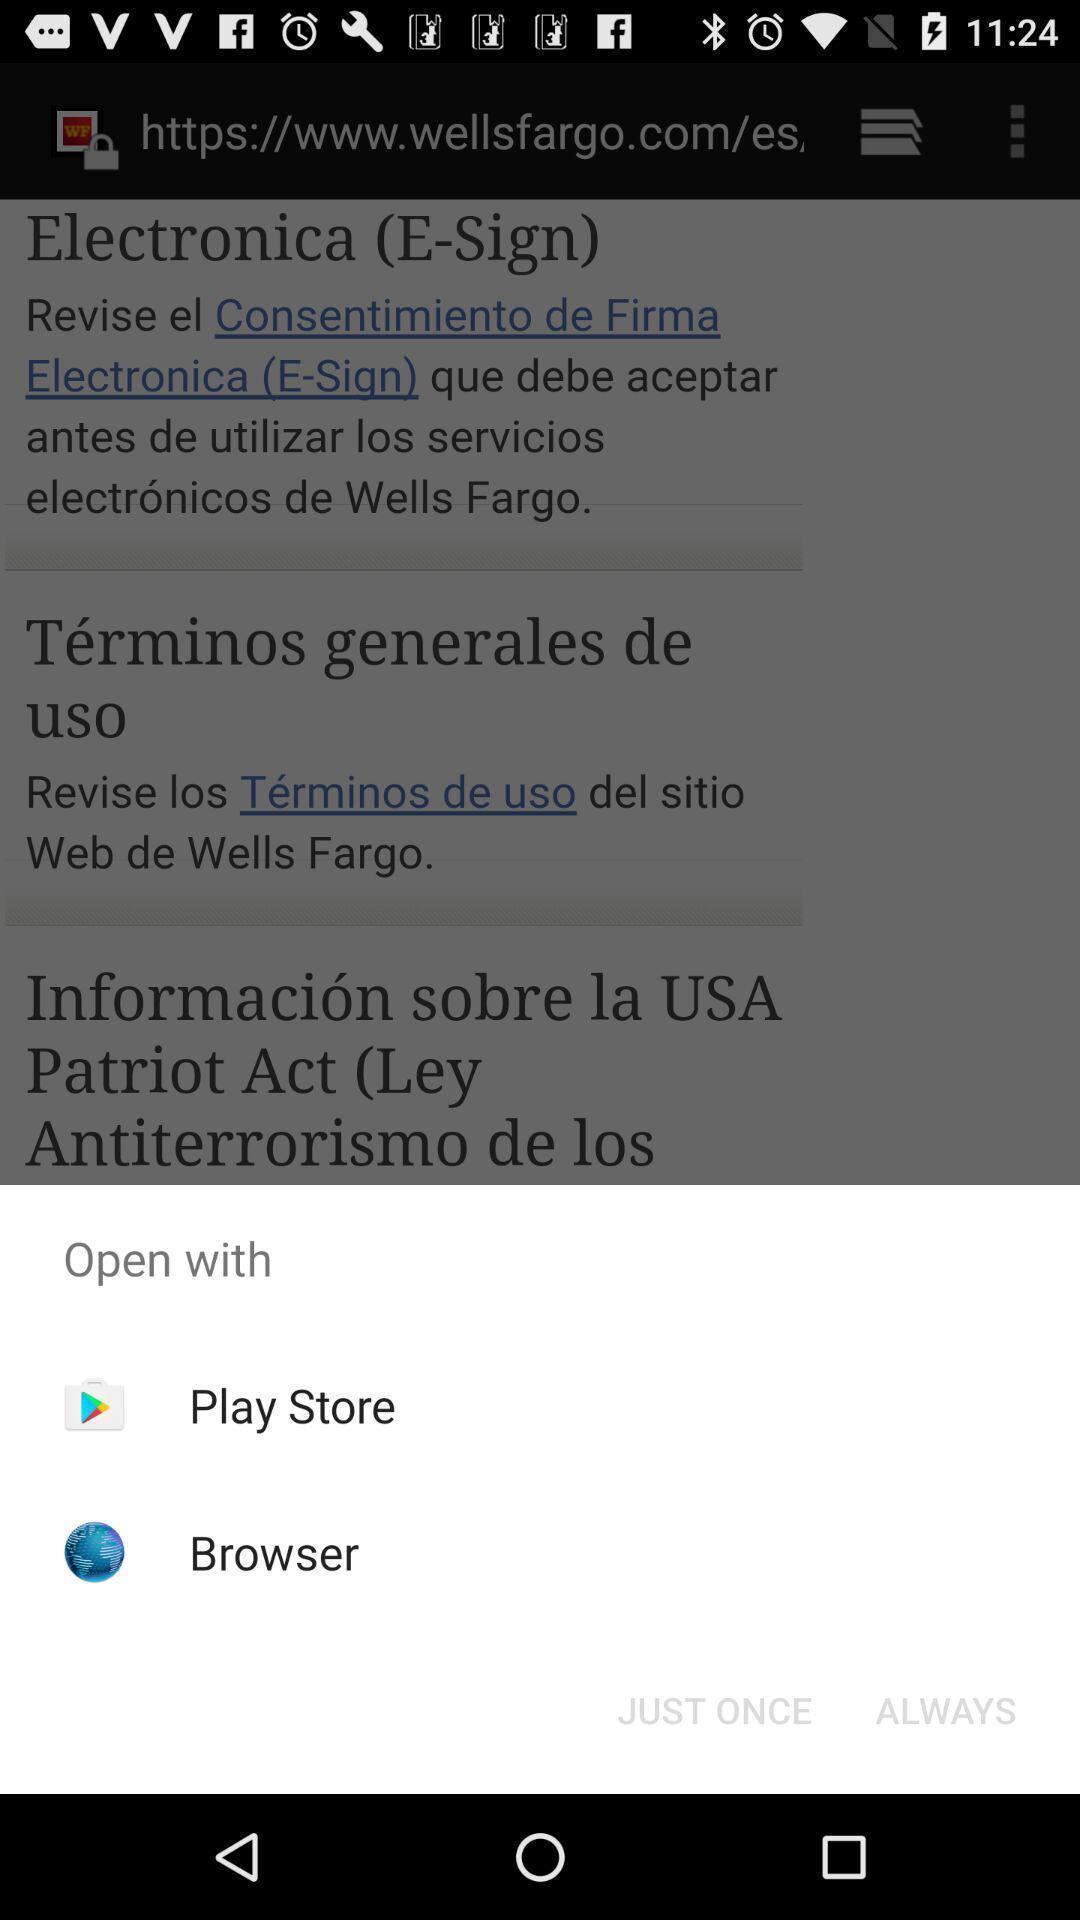What details can you identify in this image? Popup showing few options with icons. 